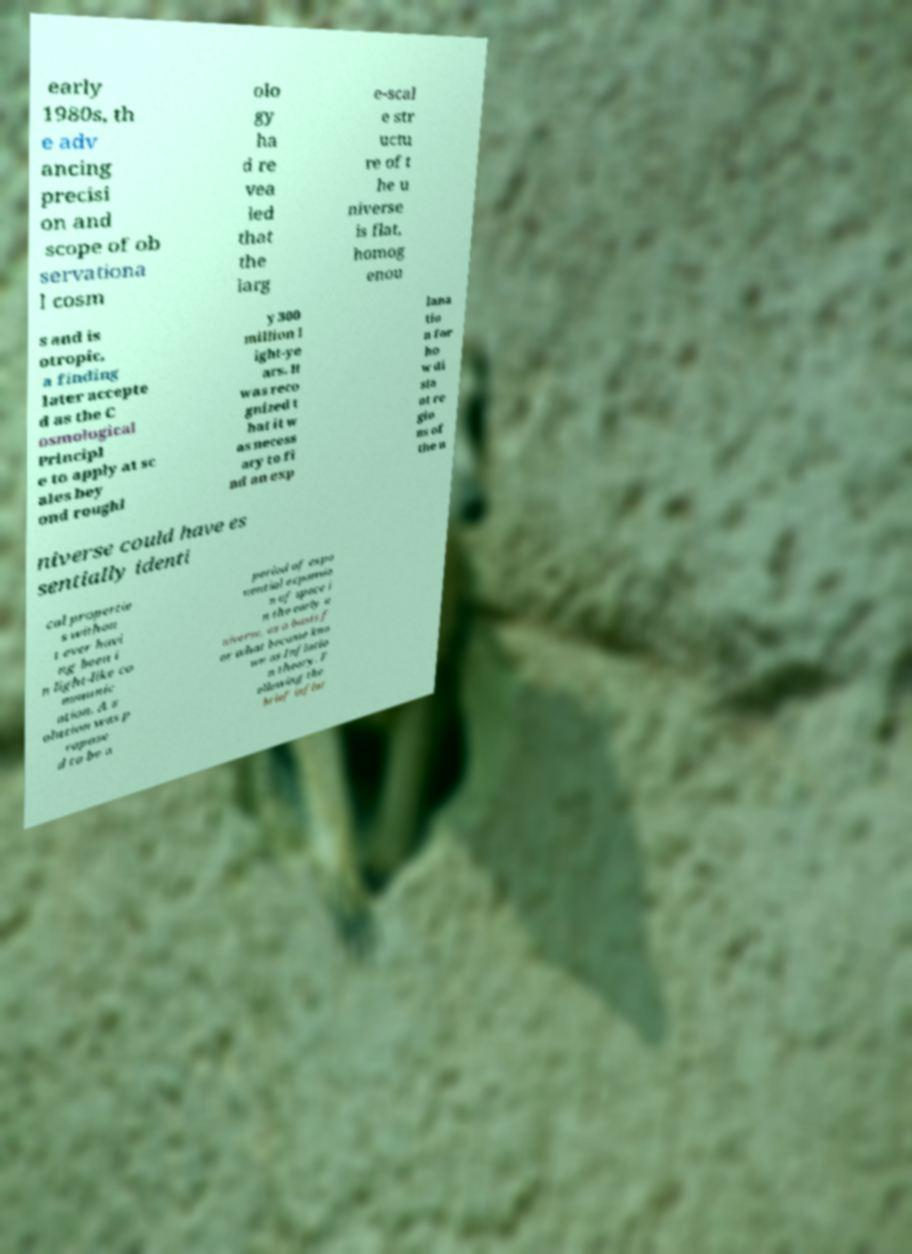Could you assist in decoding the text presented in this image and type it out clearly? early 1980s, th e adv ancing precisi on and scope of ob servationa l cosm olo gy ha d re vea led that the larg e-scal e str uctu re of t he u niverse is flat, homog enou s and is otropic, a finding later accepte d as the C osmological Principl e to apply at sc ales bey ond roughl y 300 million l ight-ye ars. It was reco gnized t hat it w as necess ary to fi nd an exp lana tio n for ho w di sta nt re gio ns of the u niverse could have es sentially identi cal propertie s withou t ever havi ng been i n light-like co mmunic ation. A s olution was p ropose d to be a period of expo nential expansio n of space i n the early u niverse, as a basis f or what became kno wn as Inflatio n theory. F ollowing the brief inflat 